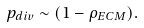<formula> <loc_0><loc_0><loc_500><loc_500>p _ { d i v } \sim ( 1 - \rho _ { E C M } ) .</formula> 